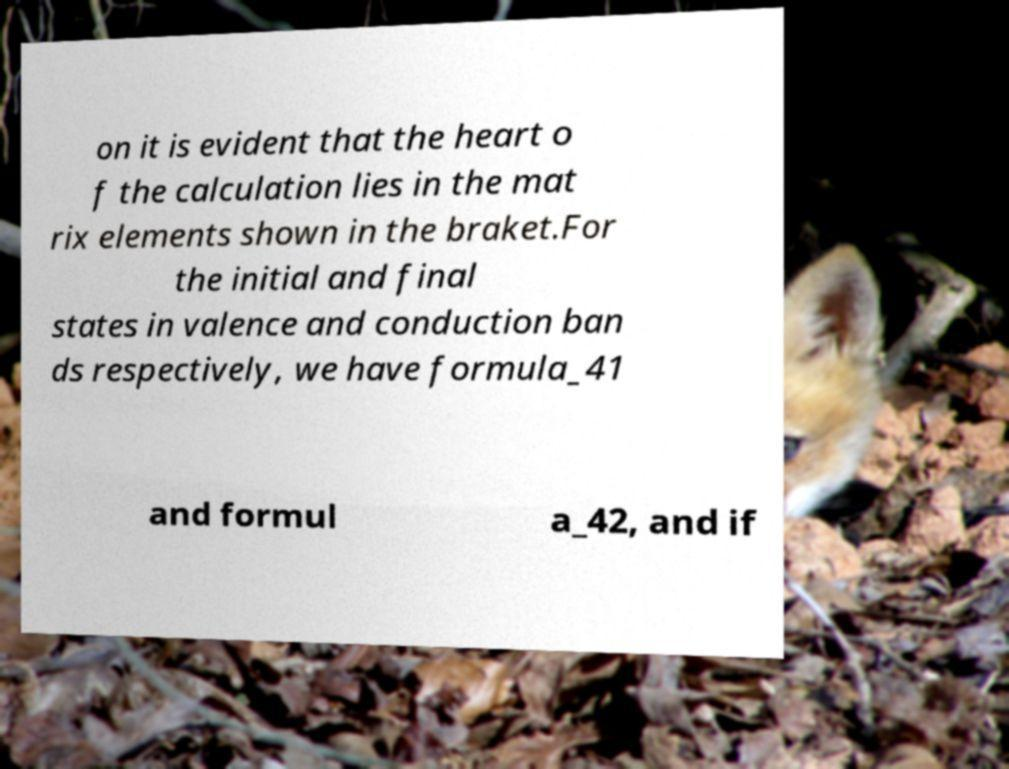There's text embedded in this image that I need extracted. Can you transcribe it verbatim? on it is evident that the heart o f the calculation lies in the mat rix elements shown in the braket.For the initial and final states in valence and conduction ban ds respectively, we have formula_41 and formul a_42, and if 